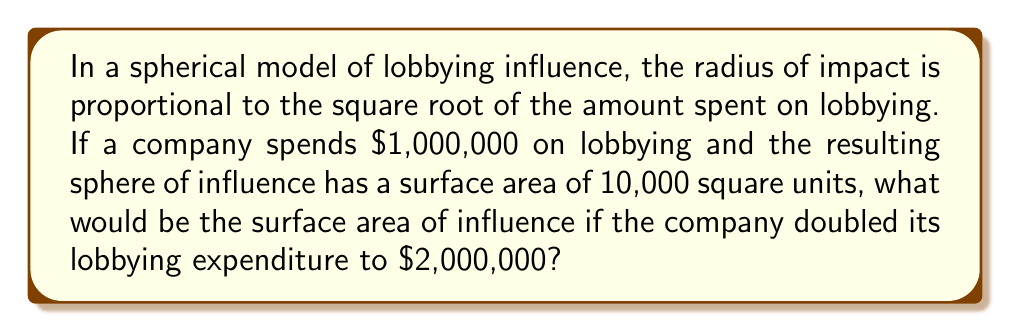Provide a solution to this math problem. Let's approach this step-by-step:

1) First, recall the formula for the surface area of a sphere:
   $$ A = 4\pi r^2 $$
   where $A$ is the surface area and $r$ is the radius.

2) We're told that the radius is proportional to the square root of the amount spent. Let's express this mathematically:
   $$ r \propto \sqrt{x} $$
   where $x$ is the amount spent on lobbying.

3) Let's say the constant of proportionality is $k$. Then:
   $$ r = k\sqrt{x} $$

4) For the initial case, where $x_1 = 1,000,000$ and $A_1 = 10,000$:
   $$ 10,000 = 4\pi (k\sqrt{1,000,000})^2 $$

5) Now, for the case where the spending is doubled, $x_2 = 2,000,000$. Let's call the new surface area $A_2$:
   $$ A_2 = 4\pi (k\sqrt{2,000,000})^2 $$

6) Dividing these equations:
   $$ \frac{A_2}{10,000} = \frac{4\pi (k\sqrt{2,000,000})^2}{4\pi (k\sqrt{1,000,000})^2} $$

7) The $4\pi$ and $k^2$ cancel out:
   $$ \frac{A_2}{10,000} = \frac{2,000,000}{1,000,000} = 2 $$

8) Therefore:
   $$ A_2 = 2 * 10,000 = 20,000 $$
Answer: 20,000 square units 